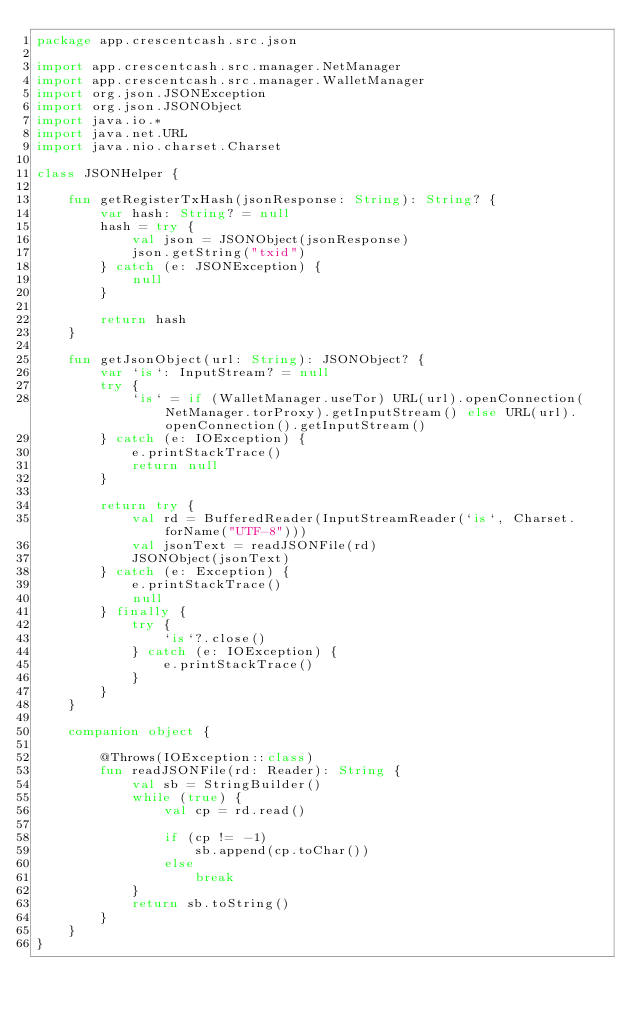<code> <loc_0><loc_0><loc_500><loc_500><_Kotlin_>package app.crescentcash.src.json

import app.crescentcash.src.manager.NetManager
import app.crescentcash.src.manager.WalletManager
import org.json.JSONException
import org.json.JSONObject
import java.io.*
import java.net.URL
import java.nio.charset.Charset

class JSONHelper {

    fun getRegisterTxHash(jsonResponse: String): String? {
        var hash: String? = null
        hash = try {
            val json = JSONObject(jsonResponse)
            json.getString("txid")
        } catch (e: JSONException) {
            null
        }

        return hash
    }

    fun getJsonObject(url: String): JSONObject? {
        var `is`: InputStream? = null
        try {
            `is` = if (WalletManager.useTor) URL(url).openConnection(NetManager.torProxy).getInputStream() else URL(url).openConnection().getInputStream()
        } catch (e: IOException) {
            e.printStackTrace()
            return null
        }

        return try {
            val rd = BufferedReader(InputStreamReader(`is`, Charset.forName("UTF-8")))
            val jsonText = readJSONFile(rd)
            JSONObject(jsonText)
        } catch (e: Exception) {
            e.printStackTrace()
            null
        } finally {
            try {
                `is`?.close()
            } catch (e: IOException) {
                e.printStackTrace()
            }
        }
    }

    companion object {

        @Throws(IOException::class)
        fun readJSONFile(rd: Reader): String {
            val sb = StringBuilder()
            while (true) {
                val cp = rd.read()

                if (cp != -1)
                    sb.append(cp.toChar())
                else
                    break
            }
            return sb.toString()
        }
    }
}
</code> 